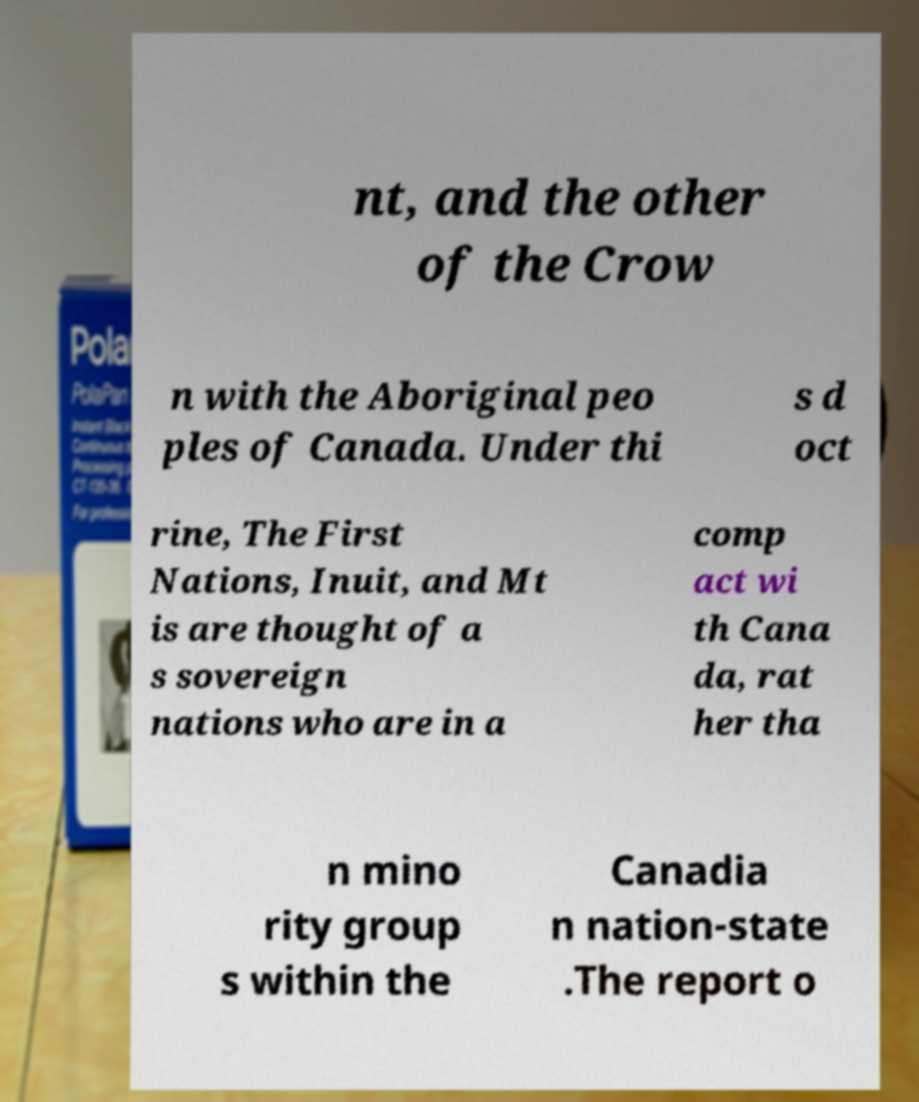Can you read and provide the text displayed in the image?This photo seems to have some interesting text. Can you extract and type it out for me? nt, and the other of the Crow n with the Aboriginal peo ples of Canada. Under thi s d oct rine, The First Nations, Inuit, and Mt is are thought of a s sovereign nations who are in a comp act wi th Cana da, rat her tha n mino rity group s within the Canadia n nation-state .The report o 